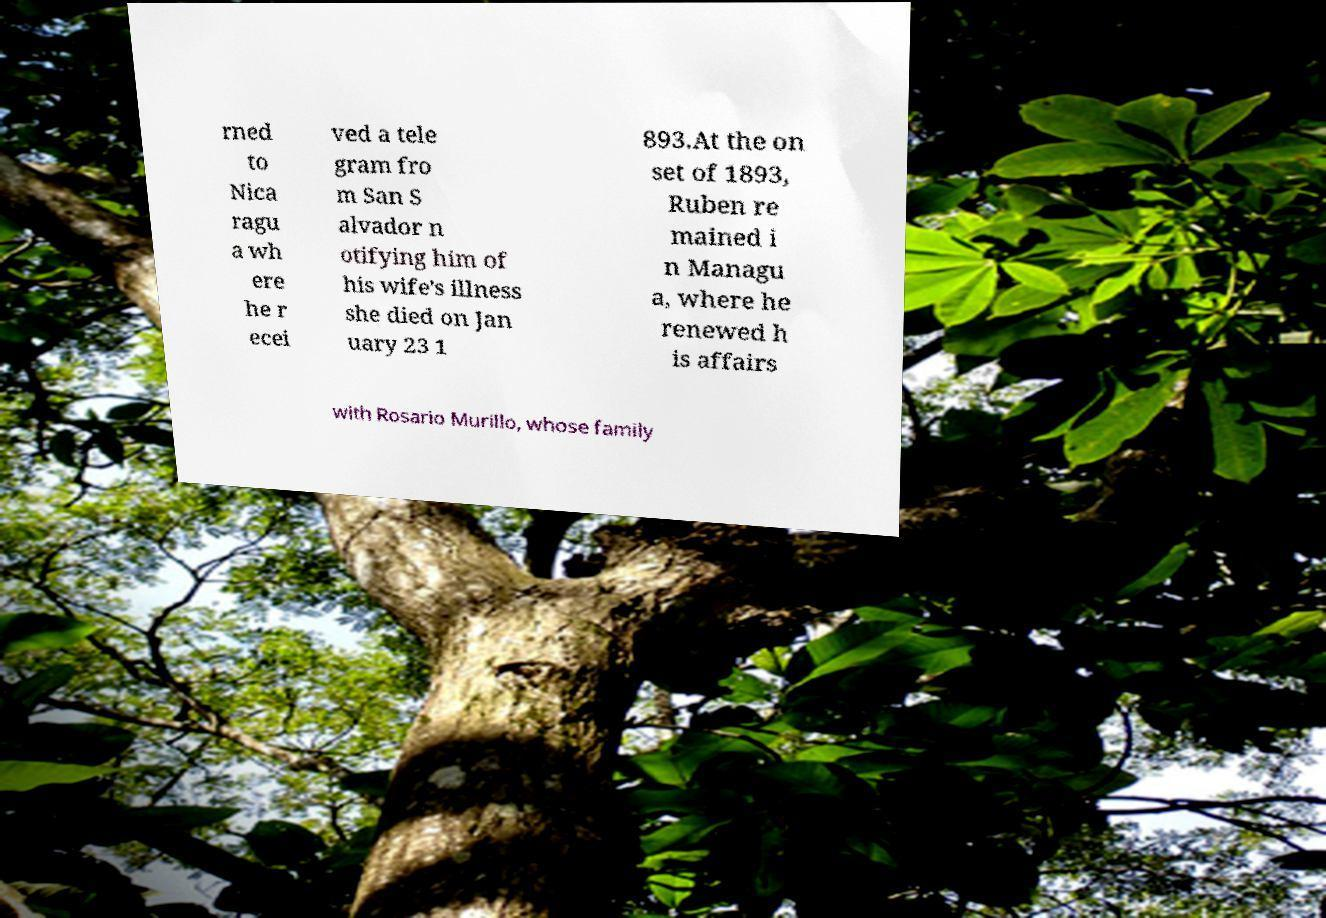Please identify and transcribe the text found in this image. rned to Nica ragu a wh ere he r ecei ved a tele gram fro m San S alvador n otifying him of his wife's illness she died on Jan uary 23 1 893.At the on set of 1893, Ruben re mained i n Managu a, where he renewed h is affairs with Rosario Murillo, whose family 